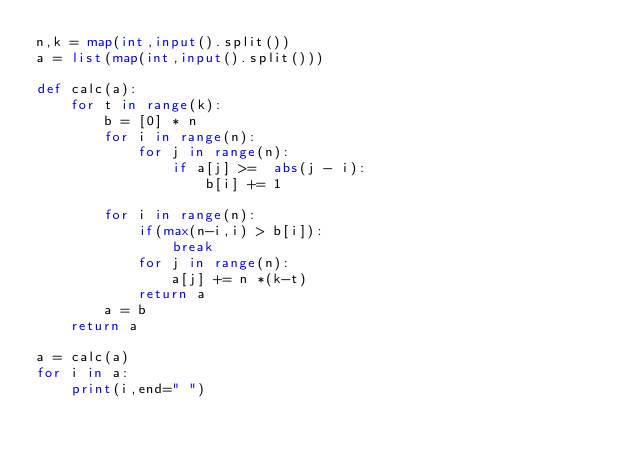Convert code to text. <code><loc_0><loc_0><loc_500><loc_500><_Python_>n,k = map(int,input().split())
a = list(map(int,input().split()))

def calc(a):
    for t in range(k):
        b = [0] * n
        for i in range(n):
            for j in range(n):
                if a[j] >=  abs(j - i):
                    b[i] += 1

        for i in range(n):
            if(max(n-i,i) > b[i]):
                break
            for j in range(n):
                a[j] += n *(k-t)
            return a
        a = b
    return a

a = calc(a)
for i in a:
    print(i,end=" ")
        </code> 